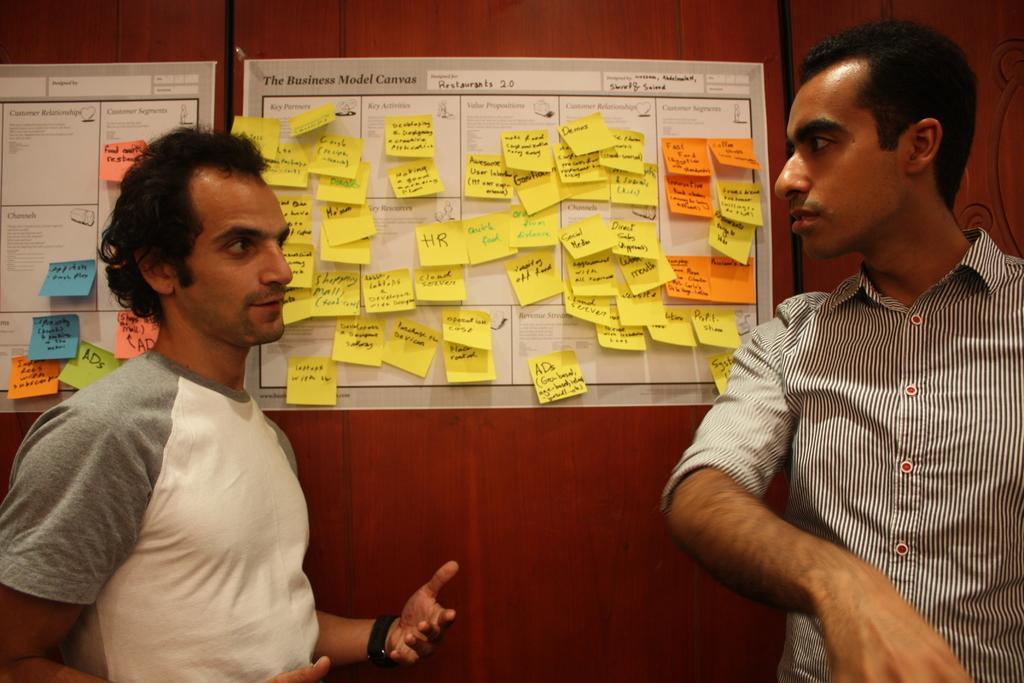Please provide a concise description of this image. This picture shows a couple of Men Standing and we see couple of posters on the wooden doors and we see stick papers on the posters. 